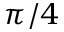Convert formula to latex. <formula><loc_0><loc_0><loc_500><loc_500>\pi / 4</formula> 